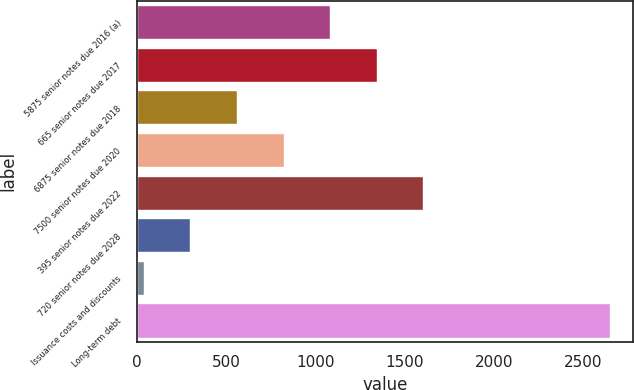Convert chart to OTSL. <chart><loc_0><loc_0><loc_500><loc_500><bar_chart><fcel>5875 senior notes due 2016 (a)<fcel>665 senior notes due 2017<fcel>6875 senior notes due 2018<fcel>7500 senior notes due 2020<fcel>395 senior notes due 2022<fcel>720 senior notes due 2028<fcel>Issuance costs and discounts<fcel>Long-term debt<nl><fcel>1083.8<fcel>1344.5<fcel>562.4<fcel>823.1<fcel>1605.2<fcel>301.7<fcel>41<fcel>2648<nl></chart> 